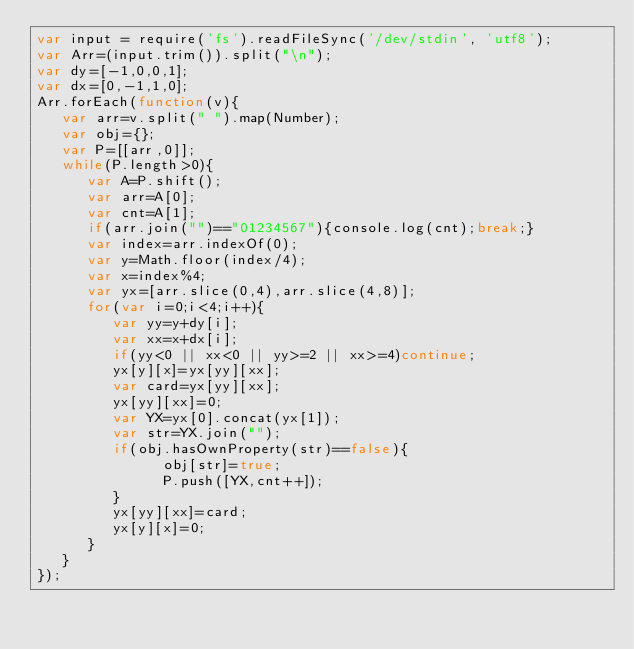<code> <loc_0><loc_0><loc_500><loc_500><_JavaScript_>var input = require('fs').readFileSync('/dev/stdin', 'utf8');
var Arr=(input.trim()).split("\n");
var dy=[-1,0,0,1];
var dx=[0,-1,1,0];
Arr.forEach(function(v){
   var arr=v.split(" ").map(Number);
   var obj={};
   var P=[[arr,0]];
   while(P.length>0){
      var A=P.shift();
      var arr=A[0];
      var cnt=A[1];
      if(arr.join("")=="01234567"){console.log(cnt);break;}
      var index=arr.indexOf(0);
      var y=Math.floor(index/4);
      var x=index%4;
      var yx=[arr.slice(0,4),arr.slice(4,8)];
      for(var i=0;i<4;i++){
         var yy=y+dy[i];
         var xx=x+dx[i];
         if(yy<0 || xx<0 || yy>=2 || xx>=4)continue;
         yx[y][x]=yx[yy][xx];
         var card=yx[yy][xx];
         yx[yy][xx]=0;
         var YX=yx[0].concat(yx[1]);
         var str=YX.join("");
         if(obj.hasOwnProperty(str)==false){
               obj[str]=true;
               P.push([YX,cnt++]);
         }
         yx[yy][xx]=card;
         yx[y][x]=0;
      }
   }
});</code> 